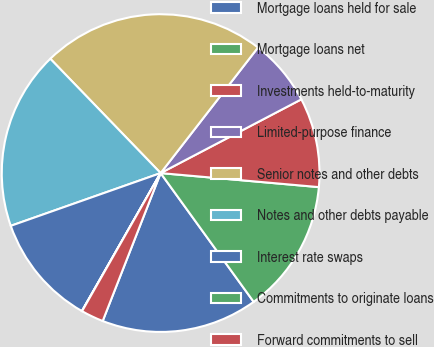Convert chart to OTSL. <chart><loc_0><loc_0><loc_500><loc_500><pie_chart><fcel>Mortgage loans held for sale<fcel>Mortgage loans net<fcel>Investments held-to-maturity<fcel>Limited-purpose finance<fcel>Senior notes and other debts<fcel>Notes and other debts payable<fcel>Interest rate swaps<fcel>Commitments to originate loans<fcel>Forward commitments to sell<nl><fcel>15.9%<fcel>13.63%<fcel>9.09%<fcel>6.82%<fcel>22.71%<fcel>18.17%<fcel>11.36%<fcel>0.02%<fcel>2.29%<nl></chart> 